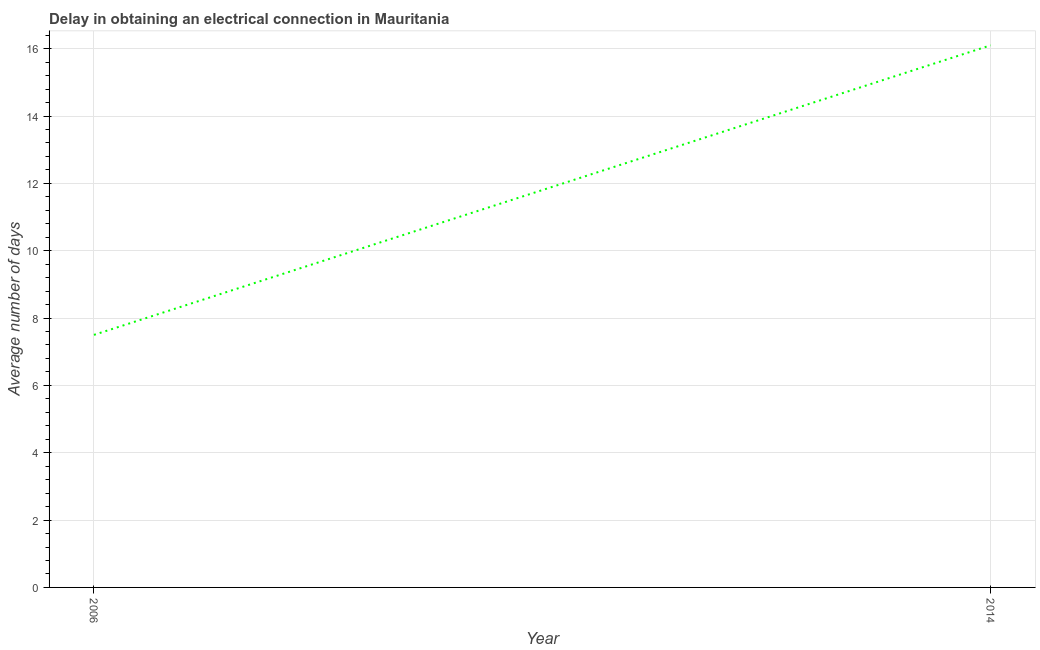What is the dalay in electrical connection in 2014?
Provide a short and direct response. 16.1. Across all years, what is the minimum dalay in electrical connection?
Offer a terse response. 7.5. In which year was the dalay in electrical connection maximum?
Give a very brief answer. 2014. In which year was the dalay in electrical connection minimum?
Offer a terse response. 2006. What is the sum of the dalay in electrical connection?
Give a very brief answer. 23.6. What is the difference between the dalay in electrical connection in 2006 and 2014?
Provide a short and direct response. -8.6. What is the average dalay in electrical connection per year?
Provide a succinct answer. 11.8. What is the median dalay in electrical connection?
Your response must be concise. 11.8. What is the ratio of the dalay in electrical connection in 2006 to that in 2014?
Make the answer very short. 0.47. Is the dalay in electrical connection in 2006 less than that in 2014?
Give a very brief answer. Yes. Does the dalay in electrical connection monotonically increase over the years?
Offer a very short reply. Yes. How many years are there in the graph?
Offer a very short reply. 2. Are the values on the major ticks of Y-axis written in scientific E-notation?
Provide a short and direct response. No. Does the graph contain any zero values?
Your response must be concise. No. What is the title of the graph?
Your response must be concise. Delay in obtaining an electrical connection in Mauritania. What is the label or title of the X-axis?
Keep it short and to the point. Year. What is the label or title of the Y-axis?
Provide a short and direct response. Average number of days. What is the difference between the Average number of days in 2006 and 2014?
Offer a very short reply. -8.6. What is the ratio of the Average number of days in 2006 to that in 2014?
Ensure brevity in your answer.  0.47. 